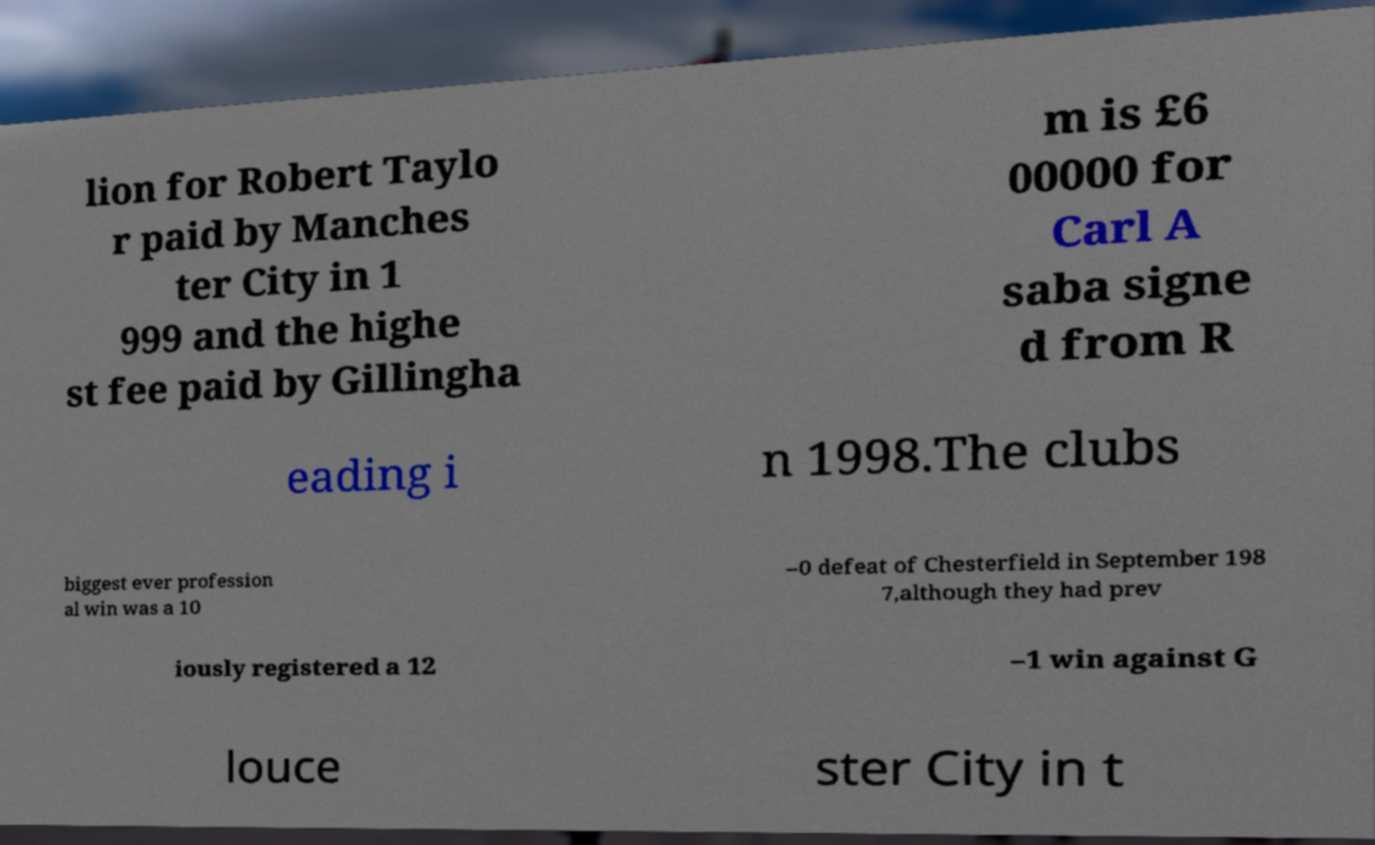Can you read and provide the text displayed in the image?This photo seems to have some interesting text. Can you extract and type it out for me? lion for Robert Taylo r paid by Manches ter City in 1 999 and the highe st fee paid by Gillingha m is £6 00000 for Carl A saba signe d from R eading i n 1998.The clubs biggest ever profession al win was a 10 –0 defeat of Chesterfield in September 198 7,although they had prev iously registered a 12 –1 win against G louce ster City in t 